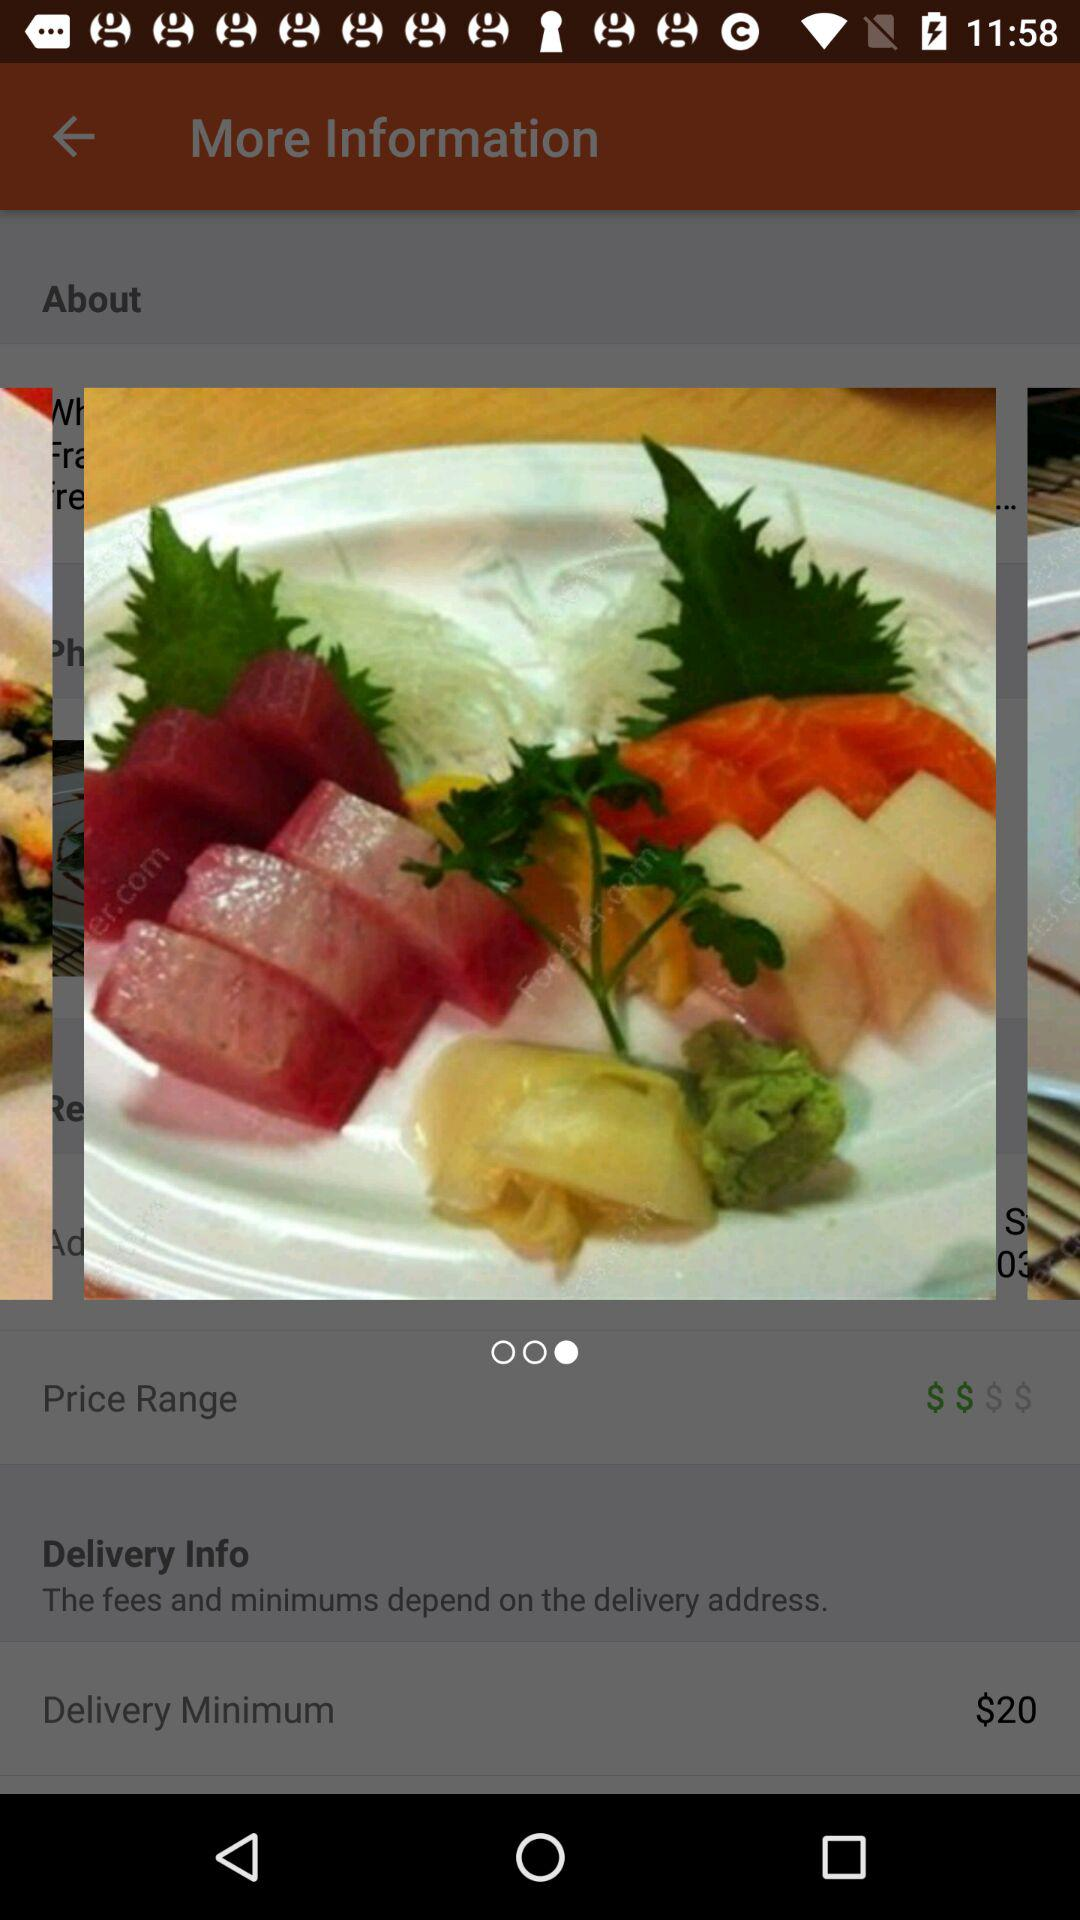How much is the delivery minimum?
Answer the question using a single word or phrase. $20 